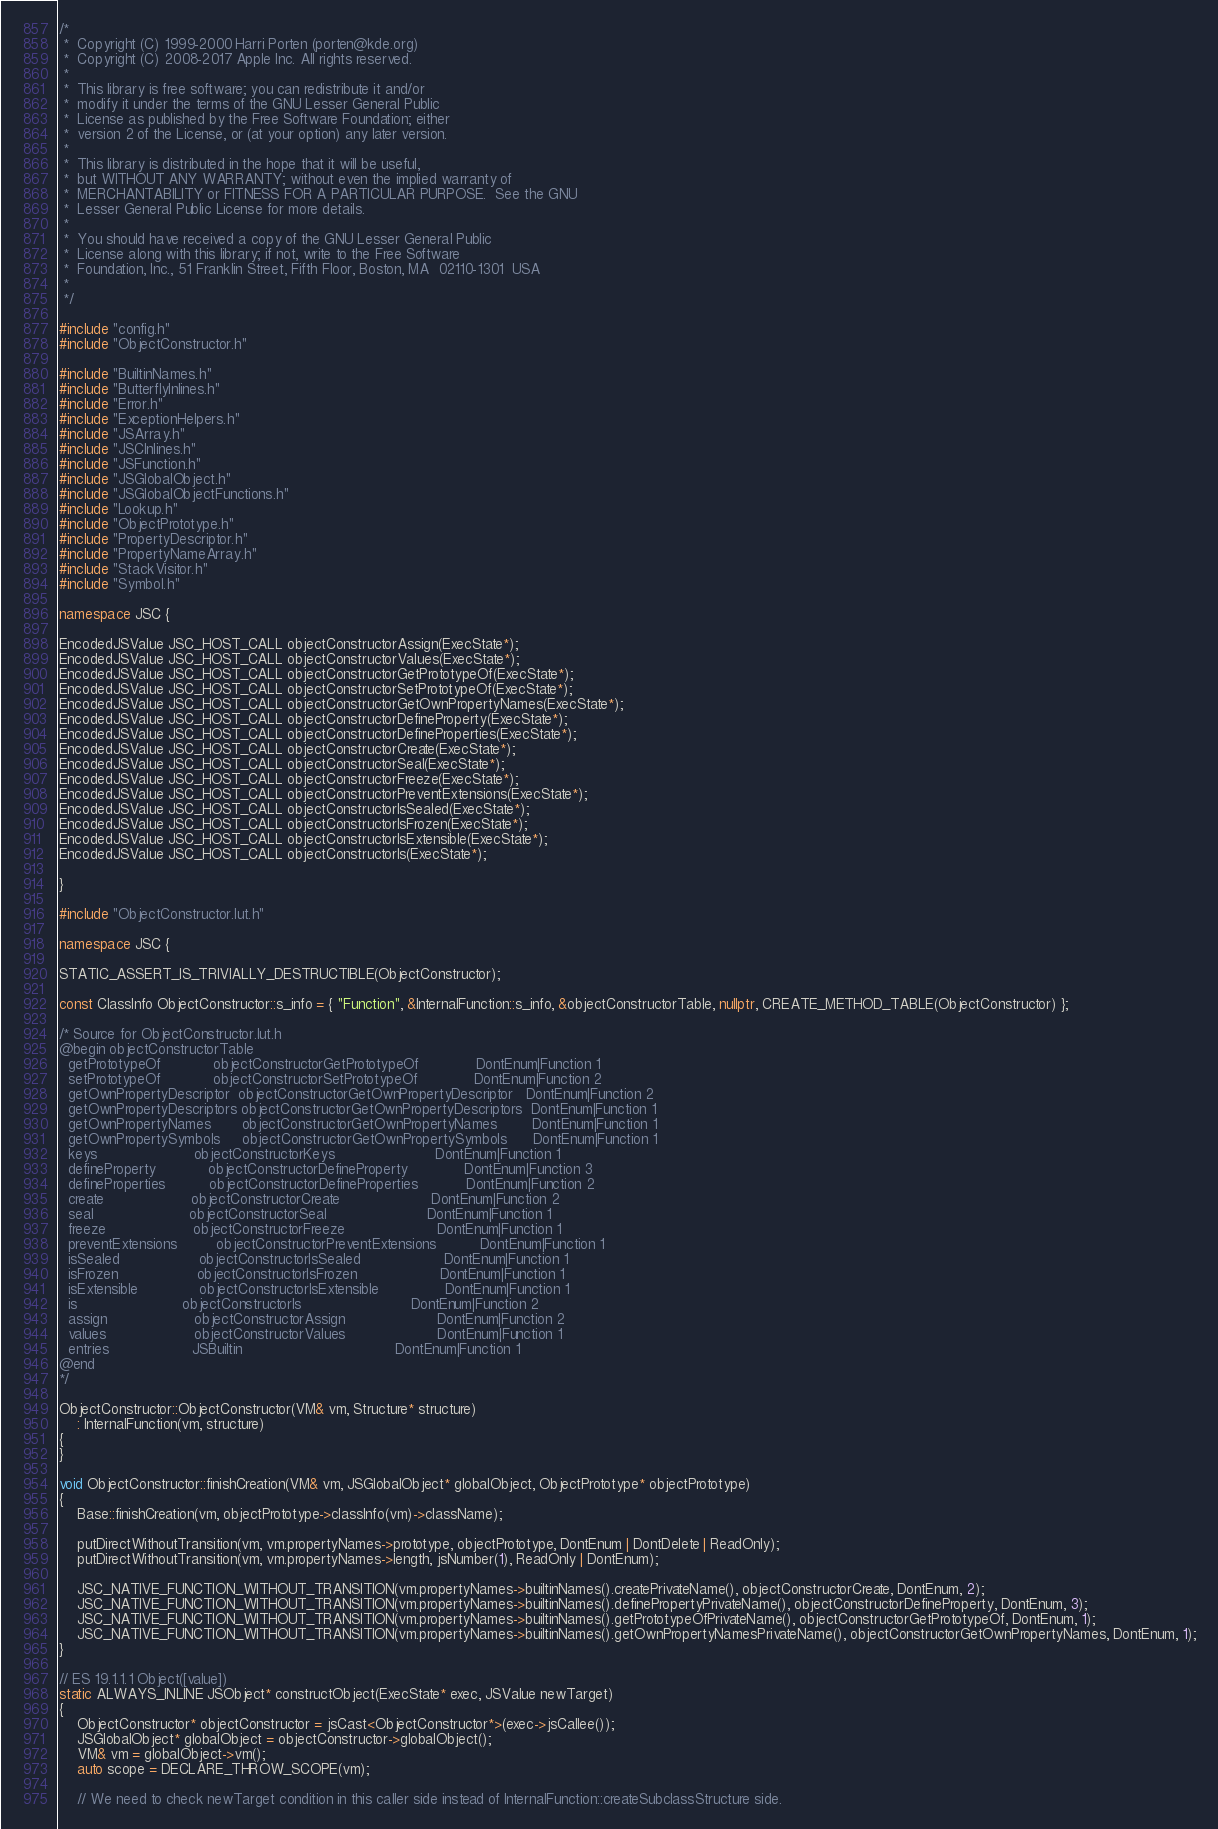Convert code to text. <code><loc_0><loc_0><loc_500><loc_500><_C++_>/*
 *  Copyright (C) 1999-2000 Harri Porten (porten@kde.org)
 *  Copyright (C) 2008-2017 Apple Inc. All rights reserved.
 *
 *  This library is free software; you can redistribute it and/or
 *  modify it under the terms of the GNU Lesser General Public
 *  License as published by the Free Software Foundation; either
 *  version 2 of the License, or (at your option) any later version.
 *
 *  This library is distributed in the hope that it will be useful,
 *  but WITHOUT ANY WARRANTY; without even the implied warranty of
 *  MERCHANTABILITY or FITNESS FOR A PARTICULAR PURPOSE.  See the GNU
 *  Lesser General Public License for more details.
 *
 *  You should have received a copy of the GNU Lesser General Public
 *  License along with this library; if not, write to the Free Software
 *  Foundation, Inc., 51 Franklin Street, Fifth Floor, Boston, MA  02110-1301  USA
 *
 */

#include "config.h"
#include "ObjectConstructor.h"

#include "BuiltinNames.h"
#include "ButterflyInlines.h"
#include "Error.h"
#include "ExceptionHelpers.h"
#include "JSArray.h"
#include "JSCInlines.h"
#include "JSFunction.h"
#include "JSGlobalObject.h"
#include "JSGlobalObjectFunctions.h"
#include "Lookup.h"
#include "ObjectPrototype.h"
#include "PropertyDescriptor.h"
#include "PropertyNameArray.h"
#include "StackVisitor.h"
#include "Symbol.h"

namespace JSC {

EncodedJSValue JSC_HOST_CALL objectConstructorAssign(ExecState*);
EncodedJSValue JSC_HOST_CALL objectConstructorValues(ExecState*);
EncodedJSValue JSC_HOST_CALL objectConstructorGetPrototypeOf(ExecState*);
EncodedJSValue JSC_HOST_CALL objectConstructorSetPrototypeOf(ExecState*);
EncodedJSValue JSC_HOST_CALL objectConstructorGetOwnPropertyNames(ExecState*);
EncodedJSValue JSC_HOST_CALL objectConstructorDefineProperty(ExecState*);
EncodedJSValue JSC_HOST_CALL objectConstructorDefineProperties(ExecState*);
EncodedJSValue JSC_HOST_CALL objectConstructorCreate(ExecState*);
EncodedJSValue JSC_HOST_CALL objectConstructorSeal(ExecState*);
EncodedJSValue JSC_HOST_CALL objectConstructorFreeze(ExecState*);
EncodedJSValue JSC_HOST_CALL objectConstructorPreventExtensions(ExecState*);
EncodedJSValue JSC_HOST_CALL objectConstructorIsSealed(ExecState*);
EncodedJSValue JSC_HOST_CALL objectConstructorIsFrozen(ExecState*);
EncodedJSValue JSC_HOST_CALL objectConstructorIsExtensible(ExecState*);
EncodedJSValue JSC_HOST_CALL objectConstructorIs(ExecState*);

}

#include "ObjectConstructor.lut.h"

namespace JSC {

STATIC_ASSERT_IS_TRIVIALLY_DESTRUCTIBLE(ObjectConstructor);

const ClassInfo ObjectConstructor::s_info = { "Function", &InternalFunction::s_info, &objectConstructorTable, nullptr, CREATE_METHOD_TABLE(ObjectConstructor) };

/* Source for ObjectConstructor.lut.h
@begin objectConstructorTable
  getPrototypeOf            objectConstructorGetPrototypeOf             DontEnum|Function 1
  setPrototypeOf            objectConstructorSetPrototypeOf             DontEnum|Function 2
  getOwnPropertyDescriptor  objectConstructorGetOwnPropertyDescriptor   DontEnum|Function 2
  getOwnPropertyDescriptors objectConstructorGetOwnPropertyDescriptors  DontEnum|Function 1
  getOwnPropertyNames       objectConstructorGetOwnPropertyNames        DontEnum|Function 1
  getOwnPropertySymbols     objectConstructorGetOwnPropertySymbols      DontEnum|Function 1
  keys                      objectConstructorKeys                       DontEnum|Function 1
  defineProperty            objectConstructorDefineProperty             DontEnum|Function 3
  defineProperties          objectConstructorDefineProperties           DontEnum|Function 2
  create                    objectConstructorCreate                     DontEnum|Function 2
  seal                      objectConstructorSeal                       DontEnum|Function 1
  freeze                    objectConstructorFreeze                     DontEnum|Function 1
  preventExtensions         objectConstructorPreventExtensions          DontEnum|Function 1
  isSealed                  objectConstructorIsSealed                   DontEnum|Function 1
  isFrozen                  objectConstructorIsFrozen                   DontEnum|Function 1
  isExtensible              objectConstructorIsExtensible               DontEnum|Function 1
  is                        objectConstructorIs                         DontEnum|Function 2
  assign                    objectConstructorAssign                     DontEnum|Function 2
  values                    objectConstructorValues                     DontEnum|Function 1
  entries                   JSBuiltin                                   DontEnum|Function 1
@end
*/

ObjectConstructor::ObjectConstructor(VM& vm, Structure* structure)
    : InternalFunction(vm, structure)
{
}

void ObjectConstructor::finishCreation(VM& vm, JSGlobalObject* globalObject, ObjectPrototype* objectPrototype)
{
    Base::finishCreation(vm, objectPrototype->classInfo(vm)->className);

    putDirectWithoutTransition(vm, vm.propertyNames->prototype, objectPrototype, DontEnum | DontDelete | ReadOnly);
    putDirectWithoutTransition(vm, vm.propertyNames->length, jsNumber(1), ReadOnly | DontEnum);

    JSC_NATIVE_FUNCTION_WITHOUT_TRANSITION(vm.propertyNames->builtinNames().createPrivateName(), objectConstructorCreate, DontEnum, 2);
    JSC_NATIVE_FUNCTION_WITHOUT_TRANSITION(vm.propertyNames->builtinNames().definePropertyPrivateName(), objectConstructorDefineProperty, DontEnum, 3);
    JSC_NATIVE_FUNCTION_WITHOUT_TRANSITION(vm.propertyNames->builtinNames().getPrototypeOfPrivateName(), objectConstructorGetPrototypeOf, DontEnum, 1);
    JSC_NATIVE_FUNCTION_WITHOUT_TRANSITION(vm.propertyNames->builtinNames().getOwnPropertyNamesPrivateName(), objectConstructorGetOwnPropertyNames, DontEnum, 1);
}

// ES 19.1.1.1 Object([value])
static ALWAYS_INLINE JSObject* constructObject(ExecState* exec, JSValue newTarget)
{
    ObjectConstructor* objectConstructor = jsCast<ObjectConstructor*>(exec->jsCallee());
    JSGlobalObject* globalObject = objectConstructor->globalObject();
    VM& vm = globalObject->vm();
    auto scope = DECLARE_THROW_SCOPE(vm);

    // We need to check newTarget condition in this caller side instead of InternalFunction::createSubclassStructure side.</code> 